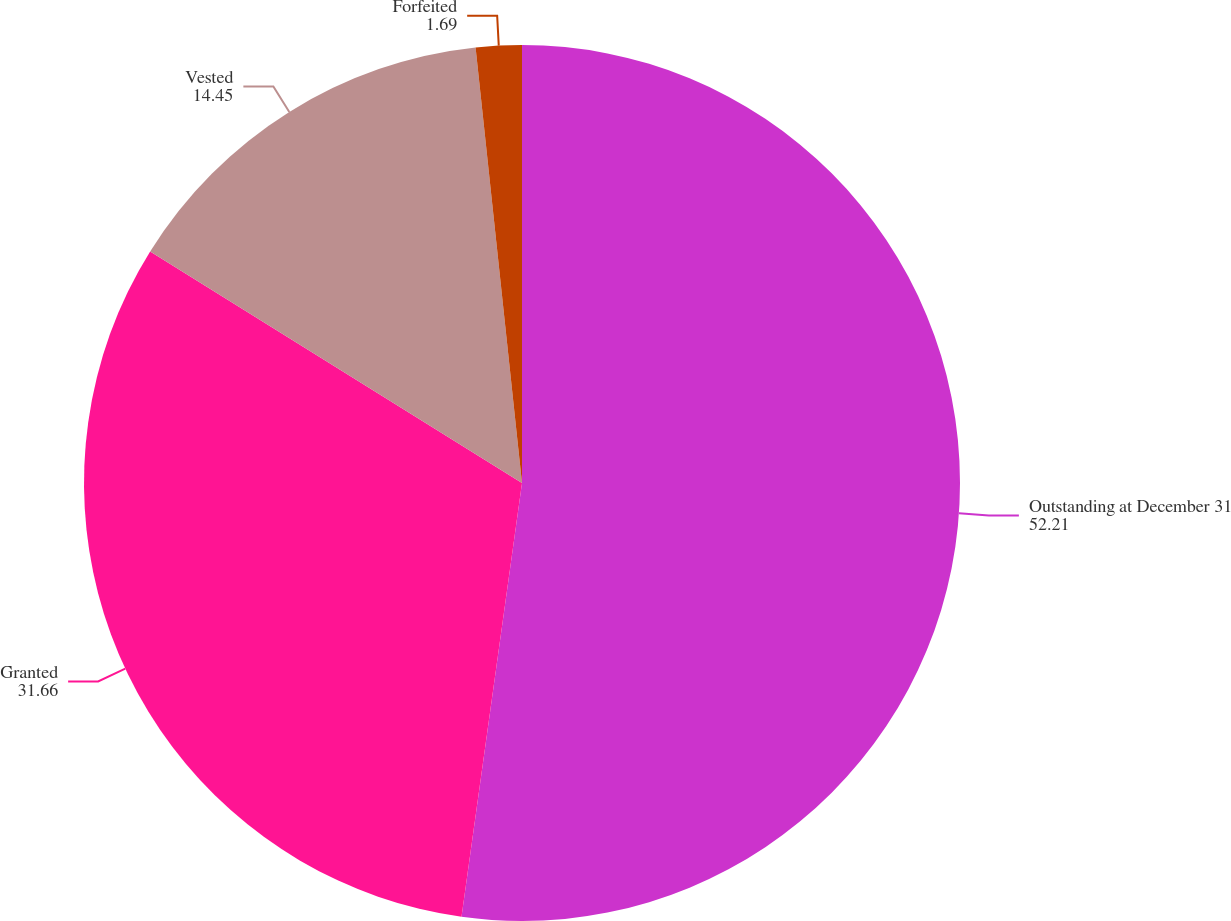Convert chart. <chart><loc_0><loc_0><loc_500><loc_500><pie_chart><fcel>Outstanding at December 31<fcel>Granted<fcel>Vested<fcel>Forfeited<nl><fcel>52.21%<fcel>31.66%<fcel>14.45%<fcel>1.69%<nl></chart> 